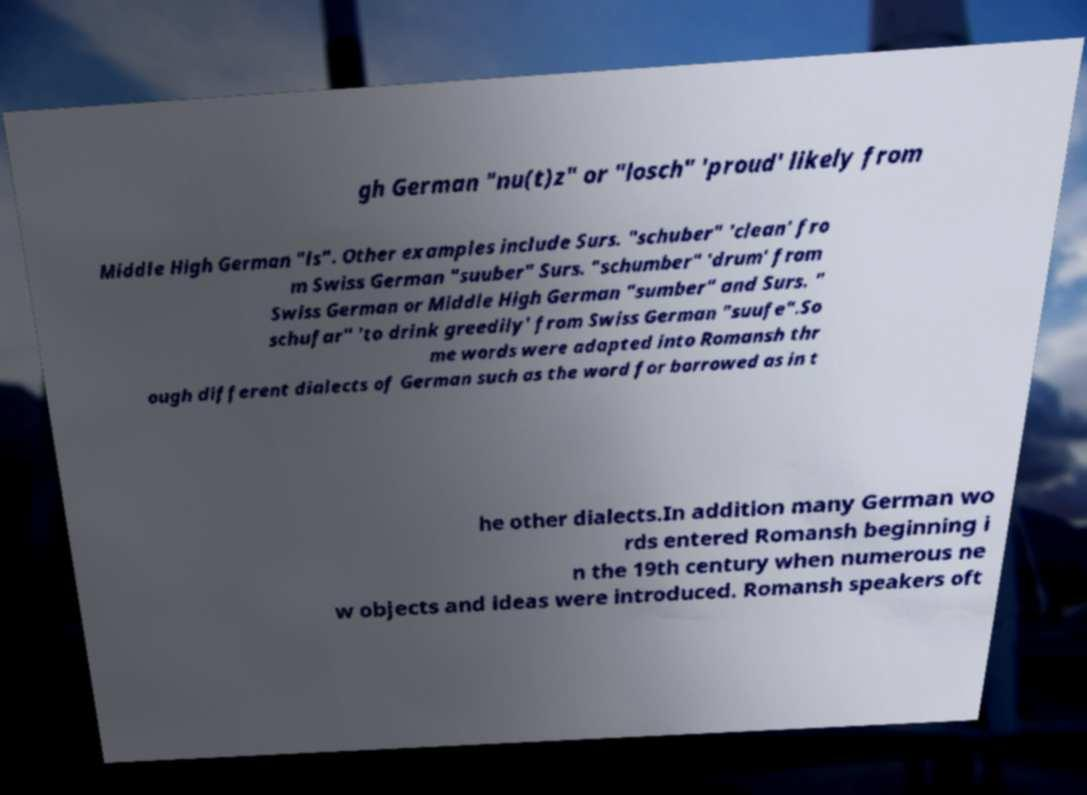Could you assist in decoding the text presented in this image and type it out clearly? gh German "nu(t)z" or "losch" 'proud' likely from Middle High German "ls". Other examples include Surs. "schuber" 'clean' fro m Swiss German "suuber" Surs. "schumber" 'drum' from Swiss German or Middle High German "sumber" and Surs. " schufar" 'to drink greedily' from Swiss German "suufe".So me words were adapted into Romansh thr ough different dialects of German such as the word for borrowed as in t he other dialects.In addition many German wo rds entered Romansh beginning i n the 19th century when numerous ne w objects and ideas were introduced. Romansh speakers oft 